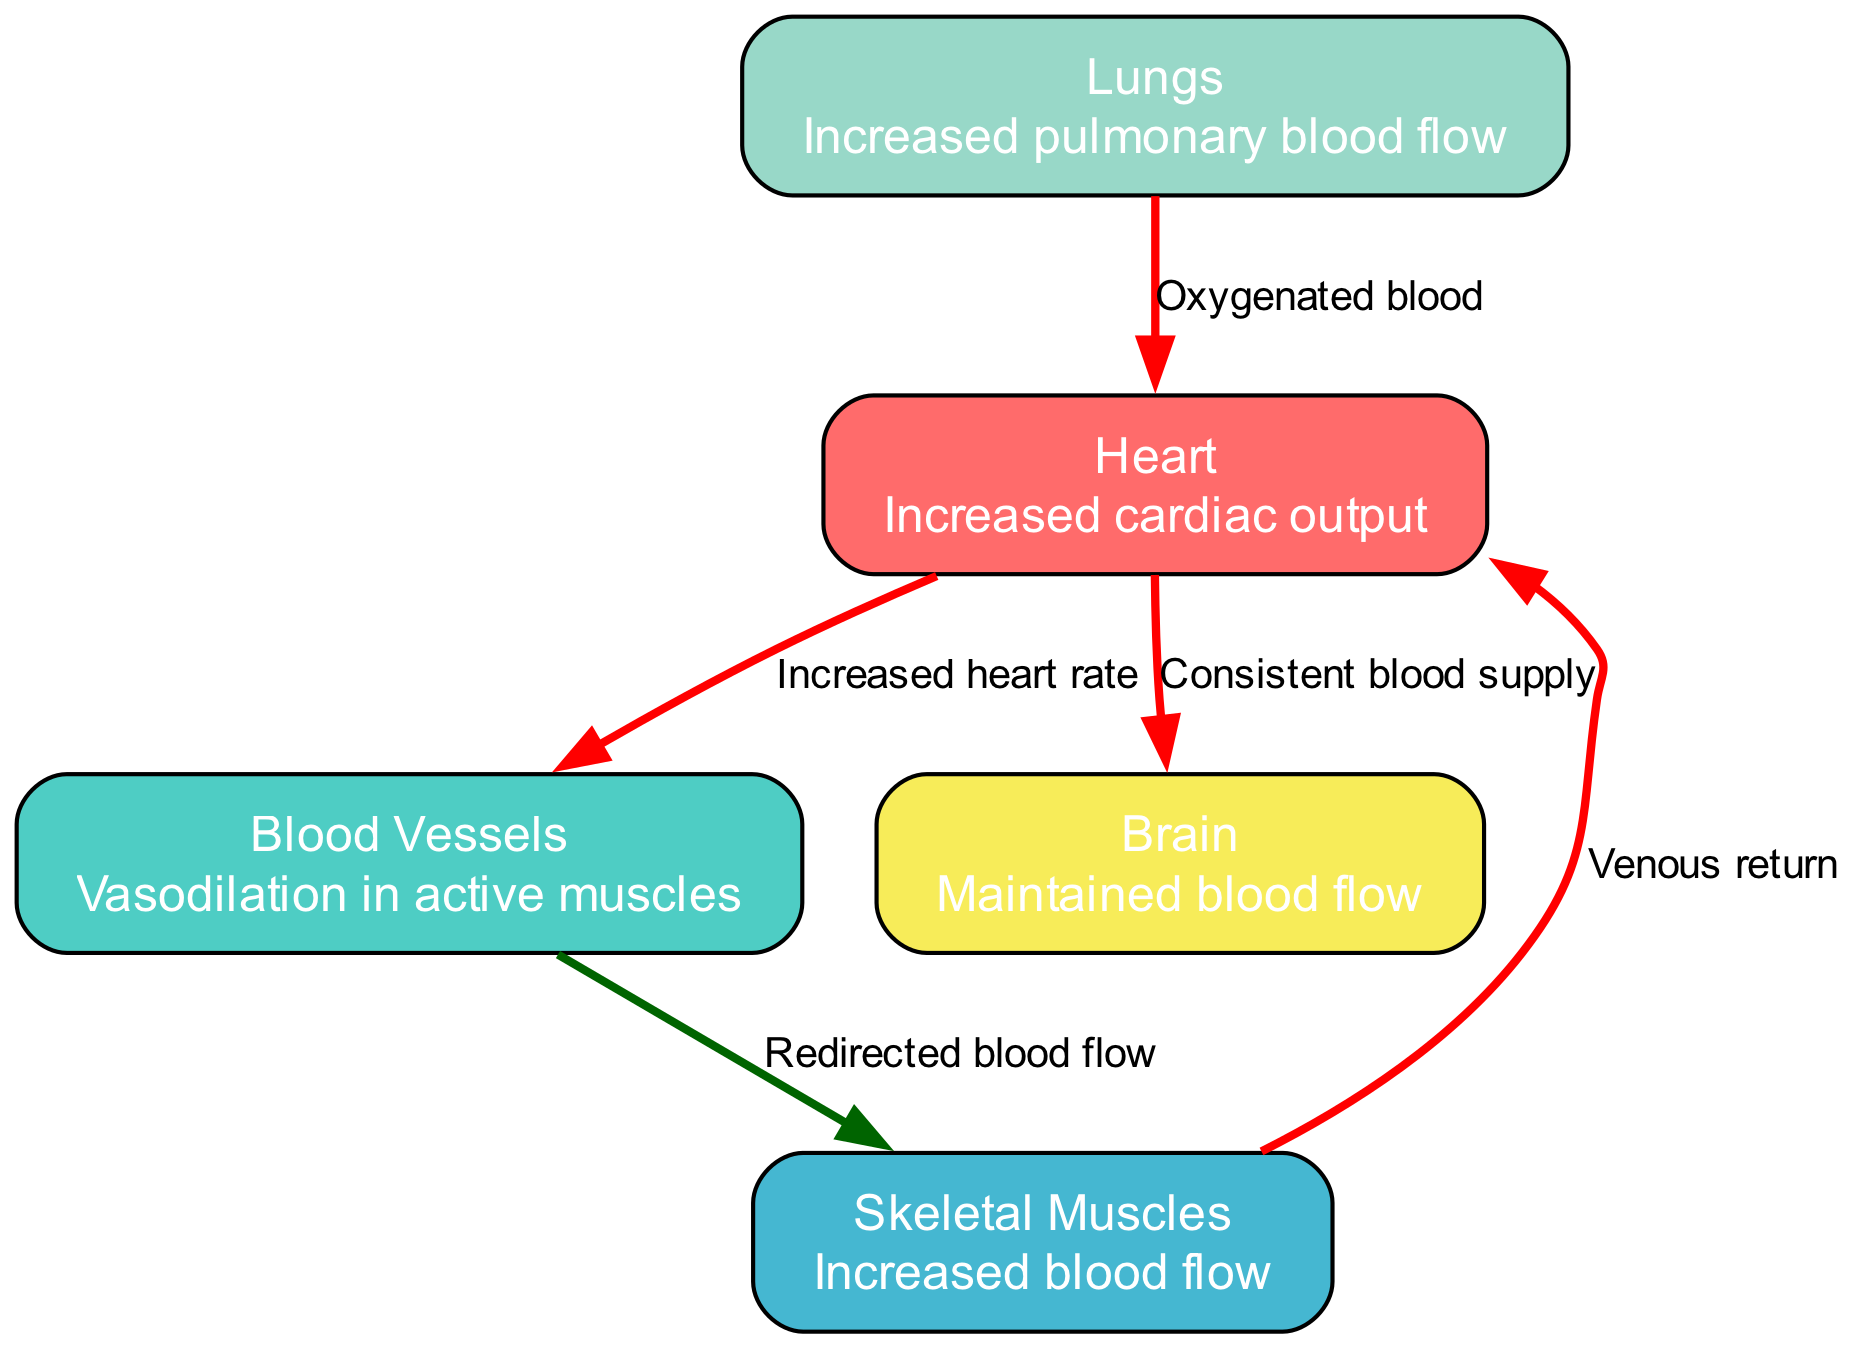What is the primary function of the heart during intense exercise? The primary function of the heart during intense exercise, as described in the diagram, is to provide increased cardiac output. This means the heart works harder and pumps more blood to meet the heightened demands of the body.
Answer: Increased cardiac output How do blood vessels respond to exercise? According to the diagram, blood vessels undergo vasodilation in active muscles during exercise. This widening of the blood vessels allows for greater blood flow to those muscles, which is essential during physical activity.
Answer: Vasodilation in active muscles What relationship is indicated between the heart and the lungs? The diagram shows a relationship where the lungs supply oxygenated blood to the heart. This connection is vital as the heart needs oxygen to pump effectively and support bodily functions during exercise.
Answer: Oxygenated blood What is redirected to skeletal muscles during exercise? The diagram indicates that blood flow is redirected to skeletal muscles during exercise. This rerouting ensures that the active muscles receive the necessary oxygen and nutrients needed for optimal performance.
Answer: Redirected blood flow How does venous return influence the heart according to the diagram? The diagram illustrates that venous return from skeletal muscles contributes to the functioning of the heart. Increased blood return from the muscles enhances the volume of blood the heart can pump, thereby increasing cardiac output.
Answer: Venous return What remains constant in terms of blood flow during exercise? The diagram specifies that blood flow to the brain is maintained even during intense exercise. This ensures that the brain continues to receive adequate blood supply for essential functions.
Answer: Maintained blood flow How many nodes are represented in the diagram? By counting the nodes displayed in the diagram, we find that there are five distinct nodes representing different components of the cardiovascular system during exercise.
Answer: 5 What is described as the effect of the heart on blood vessels? The diagram describes the effect of an increased heart rate on blood vessels. This relationship indicates that as the heart beats faster, it contributes to greater blood flow through the vessels, especially towards active muscles.
Answer: Increased heart rate What type of edge connects the lungs and heart? The edge connecting the lungs and heart is labeled as "Oxygenated blood." This signifies the direct relationship where the lungs provide oxygen-rich blood to the heart to support its functions during exercise.
Answer: Oxygenated blood 